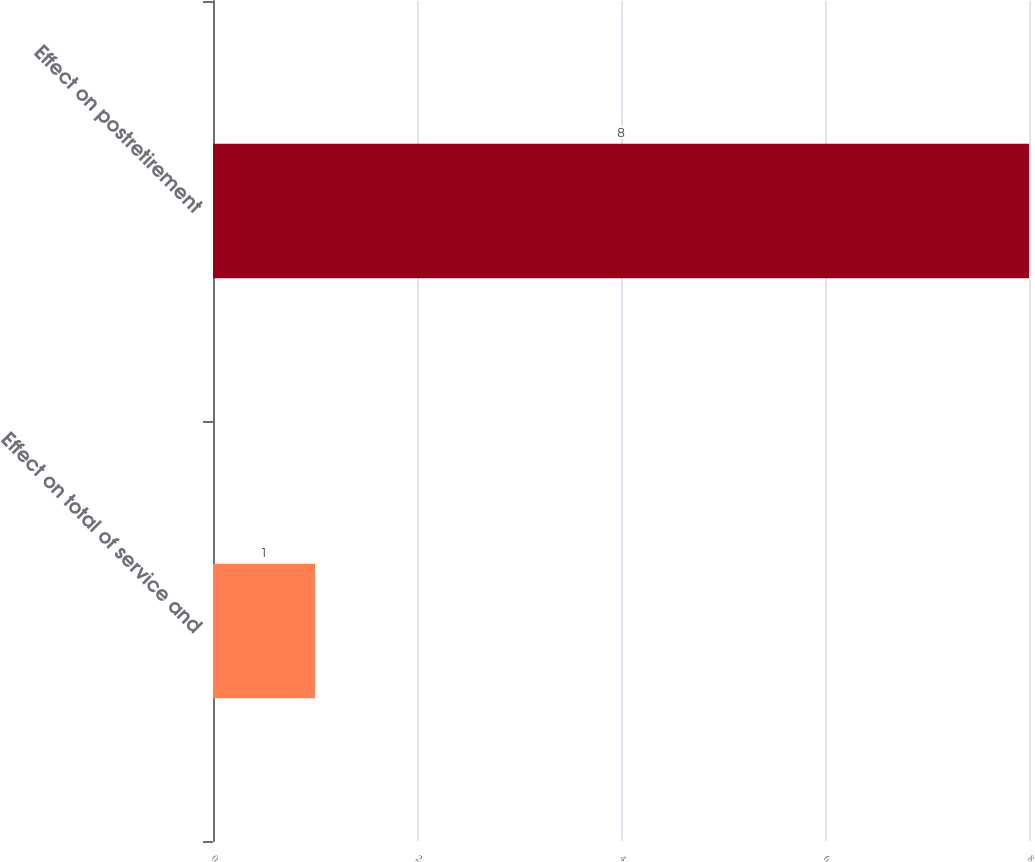<chart> <loc_0><loc_0><loc_500><loc_500><bar_chart><fcel>Effect on total of service and<fcel>Effect on postretirement<nl><fcel>1<fcel>8<nl></chart> 